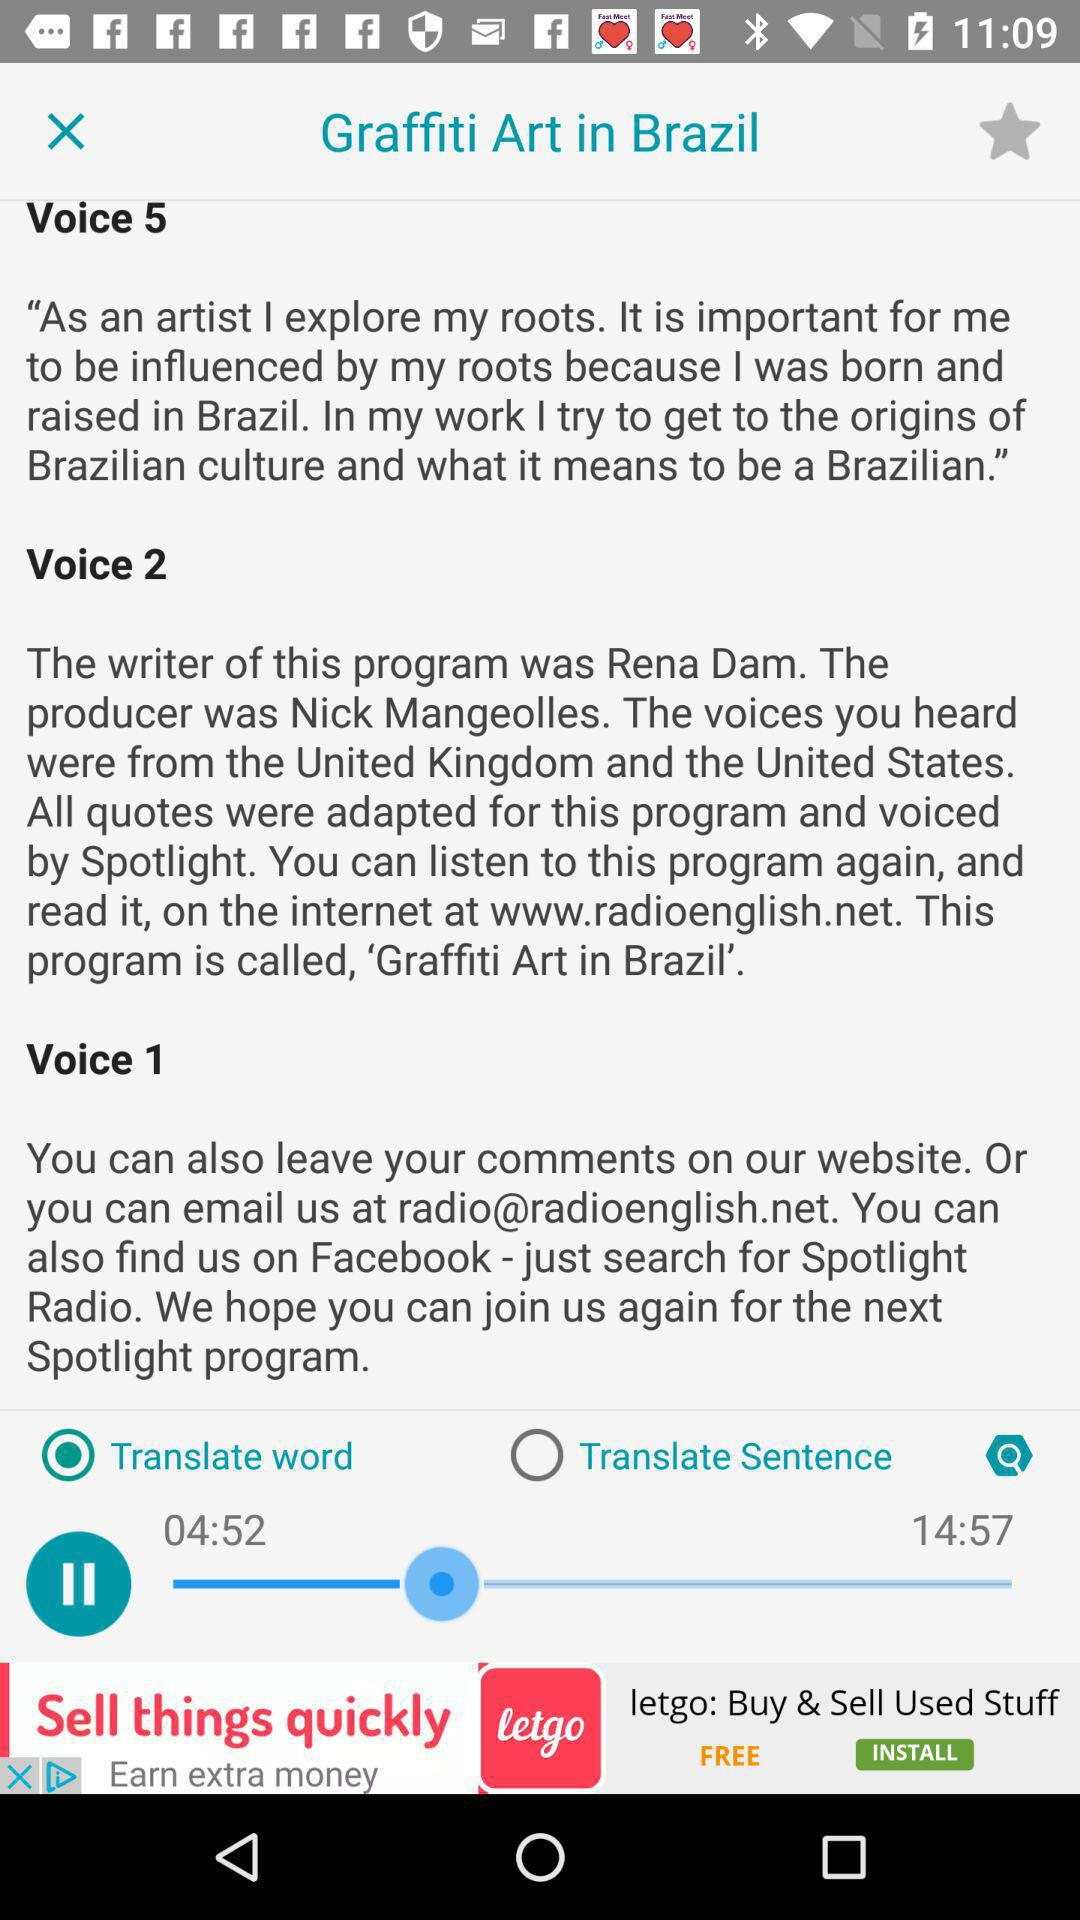What's the duration of the audio file? The duration is 14:57. 